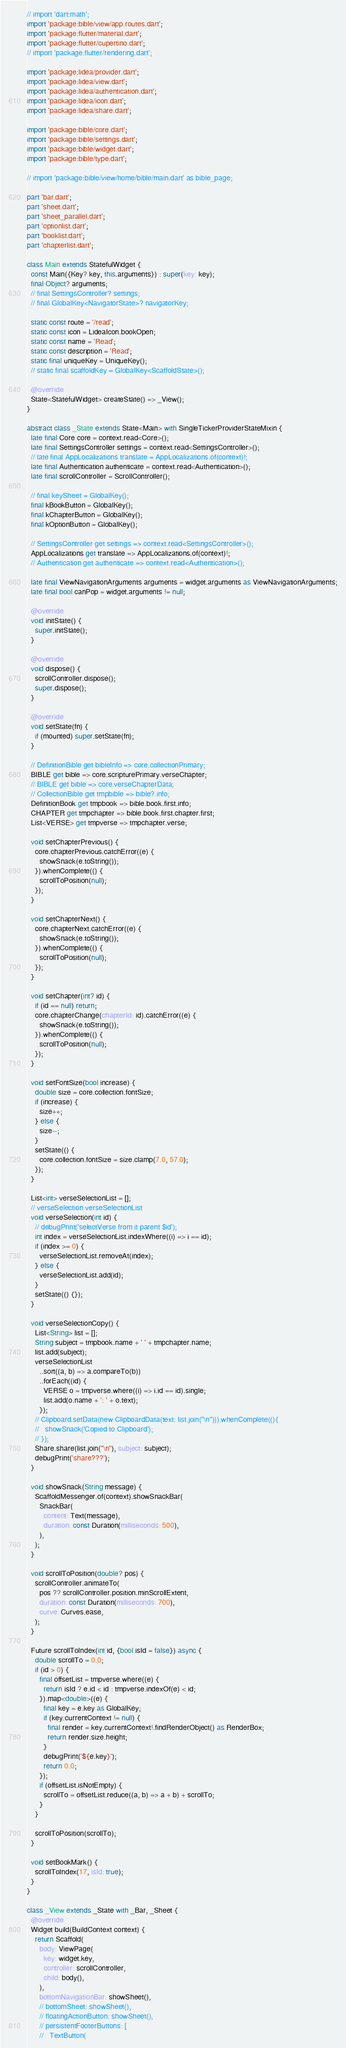<code> <loc_0><loc_0><loc_500><loc_500><_Dart_>// import 'dart:math';
import 'package:bible/view/app.routes.dart';
import 'package:flutter/material.dart';
import 'package:flutter/cupertino.dart';
// import 'package:flutter/rendering.dart';

import 'package:lidea/provider.dart';
import 'package:lidea/view.dart';
import 'package:lidea/authentication.dart';
import 'package:lidea/icon.dart';
import 'package:lidea/share.dart';

import 'package:bible/core.dart';
import 'package:bible/settings.dart';
import 'package:bible/widget.dart';
import 'package:bible/type.dart';

// import 'package:bible/view/home/bible/main.dart' as bible_page;

part 'bar.dart';
part 'sheet.dart';
part 'sheet_parallel.dart';
part 'optionlist.dart';
part 'booklist.dart';
part 'chapterlist.dart';

class Main extends StatefulWidget {
  const Main({Key? key, this.arguments}) : super(key: key);
  final Object? arguments;
  // final SettingsController? settings;
  // final GlobalKey<NavigatorState>? navigatorKey;

  static const route = '/read';
  static const icon = LideaIcon.bookOpen;
  static const name = 'Read';
  static const description = 'Read';
  static final uniqueKey = UniqueKey();
  // static final scaffoldKey = GlobalKey<ScaffoldState>();

  @override
  State<StatefulWidget> createState() => _View();
}

abstract class _State extends State<Main> with SingleTickerProviderStateMixin {
  late final Core core = context.read<Core>();
  late final SettingsController settings = context.read<SettingsController>();
  // late final AppLocalizations translate = AppLocalizations.of(context)!;
  late final Authentication authenticate = context.read<Authentication>();
  late final scrollController = ScrollController();

  // final keySheet = GlobalKey();
  final kBookButton = GlobalKey();
  final kChapterButton = GlobalKey();
  final kOptionButton = GlobalKey();

  // SettingsController get settings => context.read<SettingsController>();
  AppLocalizations get translate => AppLocalizations.of(context)!;
  // Authentication get authenticate => context.read<Authentication>();

  late final ViewNavigationArguments arguments = widget.arguments as ViewNavigationArguments;
  late final bool canPop = widget.arguments != null;

  @override
  void initState() {
    super.initState();
  }

  @override
  void dispose() {
    scrollController.dispose();
    super.dispose();
  }

  @override
  void setState(fn) {
    if (mounted) super.setState(fn);
  }

  // DefinitionBible get bibleInfo => core.collectionPrimary;
  BIBLE get bible => core.scripturePrimary.verseChapter;
  // BIBLE get bible => core.verseChapterData;
  // CollectionBible get tmpbible => bible?.info;
  DefinitionBook get tmpbook => bible.book.first.info;
  CHAPTER get tmpchapter => bible.book.first.chapter.first;
  List<VERSE> get tmpverse => tmpchapter.verse;

  void setChapterPrevious() {
    core.chapterPrevious.catchError((e) {
      showSnack(e.toString());
    }).whenComplete(() {
      scrollToPosition(null);
    });
  }

  void setChapterNext() {
    core.chapterNext.catchError((e) {
      showSnack(e.toString());
    }).whenComplete(() {
      scrollToPosition(null);
    });
  }

  void setChapter(int? id) {
    if (id == null) return;
    core.chapterChange(chapterId: id).catchError((e) {
      showSnack(e.toString());
    }).whenComplete(() {
      scrollToPosition(null);
    });
  }

  void setFontSize(bool increase) {
    double size = core.collection.fontSize;
    if (increase) {
      size++;
    } else {
      size--;
    }
    setState(() {
      core.collection.fontSize = size.clamp(7.0, 57.0);
    });
  }

  List<int> verseSelectionList = [];
  // verseSelection verseSelectionList
  void verseSelection(int id) {
    // debugPrint('selectVerse from it parent $id');
    int index = verseSelectionList.indexWhere((i) => i == id);
    if (index >= 0) {
      verseSelectionList.removeAt(index);
    } else {
      verseSelectionList.add(id);
    }
    setState(() {});
  }

  void verseSelectionCopy() {
    List<String> list = [];
    String subject = tmpbook.name + ' ' + tmpchapter.name;
    list.add(subject);
    verseSelectionList
      ..sort((a, b) => a.compareTo(b))
      ..forEach((id) {
        VERSE o = tmpverse.where((i) => i.id == id).single;
        list.add(o.name + ': ' + o.text);
      });
    // Clipboard.setData(new ClipboardData(text: list.join("\n"))).whenComplete((){
    //   showSnack('Copied to Clipboard');
    // });
    Share.share(list.join("\n"), subject: subject);
    debugPrint('share???');
  }

  void showSnack(String message) {
    ScaffoldMessenger.of(context).showSnackBar(
      SnackBar(
        content: Text(message),
        duration: const Duration(milliseconds: 500),
      ),
    );
  }

  void scrollToPosition(double? pos) {
    scrollController.animateTo(
      pos ?? scrollController.position.minScrollExtent,
      duration: const Duration(milliseconds: 700),
      curve: Curves.ease,
    );
  }

  Future scrollToIndex(int id, {bool isId = false}) async {
    double scrollTo = 0.0;
    if (id > 0) {
      final offsetList = tmpverse.where((e) {
        return isId ? e.id < id : tmpverse.indexOf(e) < id;
      }).map<double>((e) {
        final key = e.key as GlobalKey;
        if (key.currentContext != null) {
          final render = key.currentContext!.findRenderObject() as RenderBox;
          return render.size.height;
        }
        debugPrint('${e.key}');
        return 0.0;
      });
      if (offsetList.isNotEmpty) {
        scrollTo = offsetList.reduce((a, b) => a + b) + scrollTo;
      }
    }

    scrollToPosition(scrollTo);
  }

  void setBookMark() {
    scrollToIndex(17, isId: true);
  }
}

class _View extends _State with _Bar, _Sheet {
  @override
  Widget build(BuildContext context) {
    return Scaffold(
      body: ViewPage(
        key: widget.key,
        controller: scrollController,
        child: body(),
      ),
      bottomNavigationBar: showSheet(),
      // bottomSheet: showSheet(),
      // floatingActionButton: showSheet(),
      // persistentFooterButtons: [
      //   TextButton(</code> 